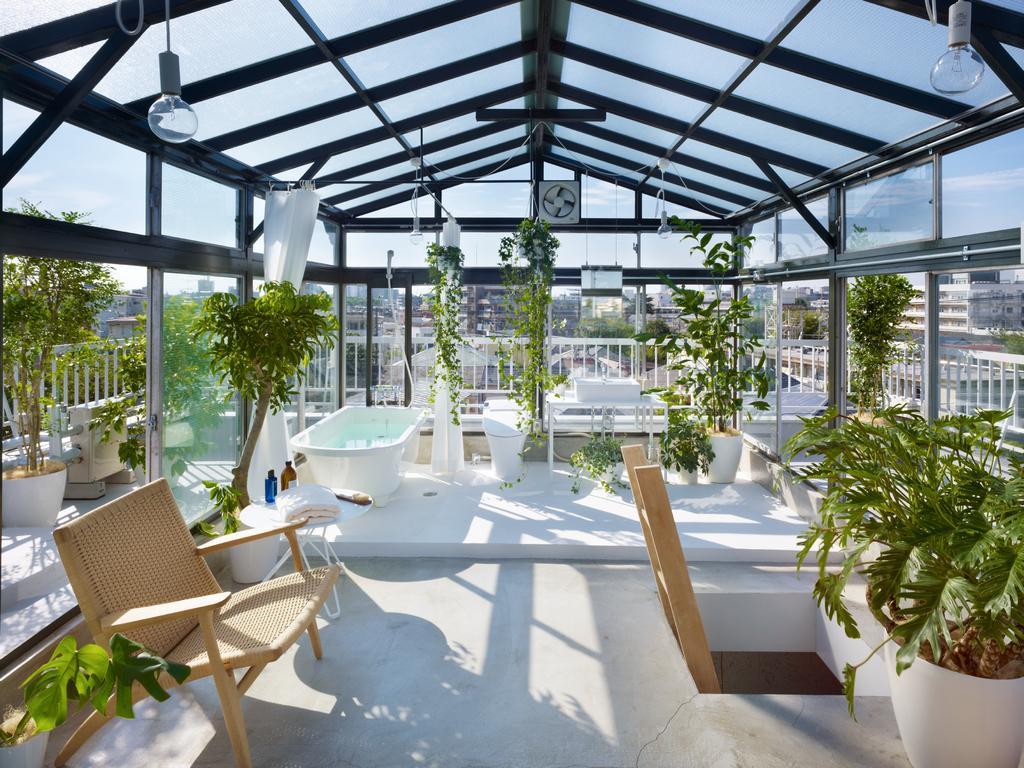In one or two sentences, can you explain what this image depicts? In this Image I see a chair, few plants, curtains, bulbs and in the background I see lot of buildings. 